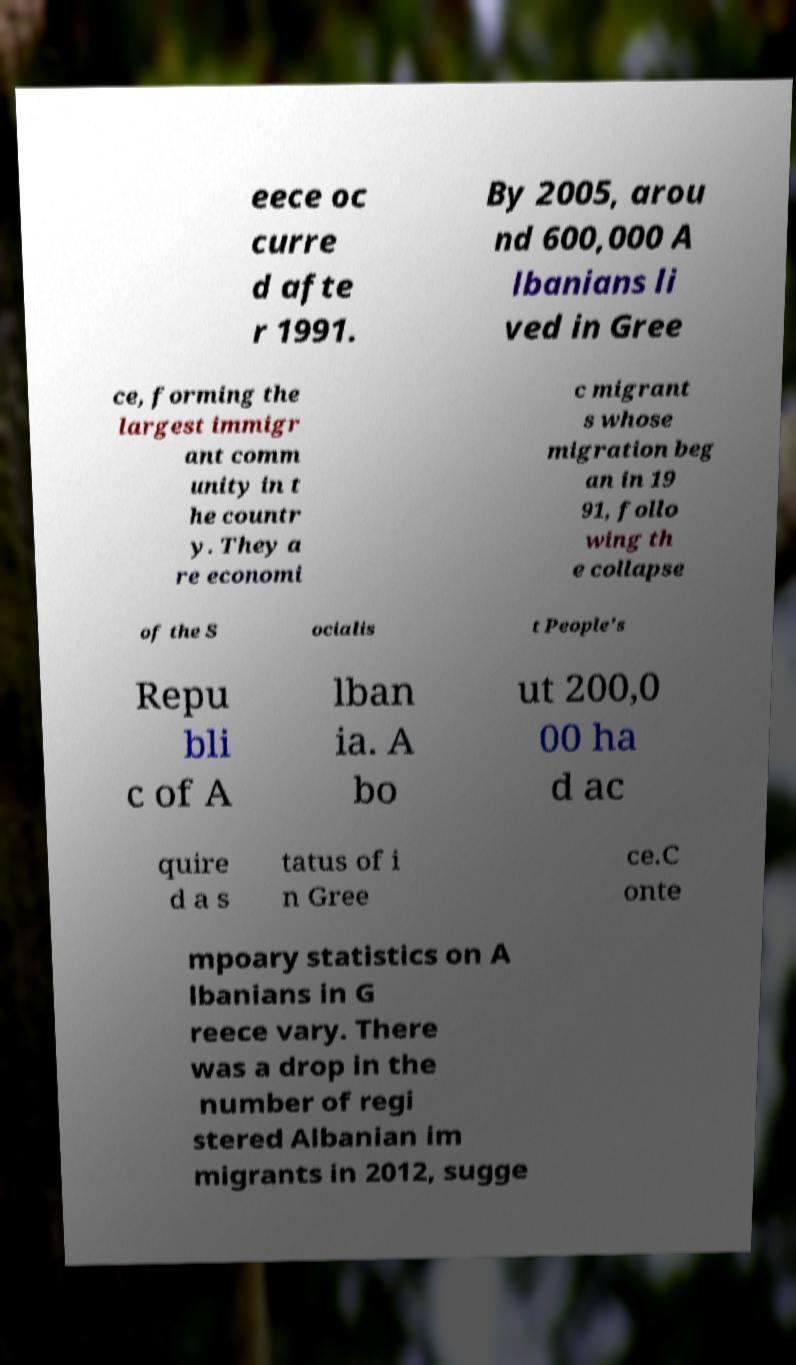There's text embedded in this image that I need extracted. Can you transcribe it verbatim? eece oc curre d afte r 1991. By 2005, arou nd 600,000 A lbanians li ved in Gree ce, forming the largest immigr ant comm unity in t he countr y. They a re economi c migrant s whose migration beg an in 19 91, follo wing th e collapse of the S ocialis t People's Repu bli c of A lban ia. A bo ut 200,0 00 ha d ac quire d a s tatus of i n Gree ce.C onte mpoary statistics on A lbanians in G reece vary. There was a drop in the number of regi stered Albanian im migrants in 2012, sugge 